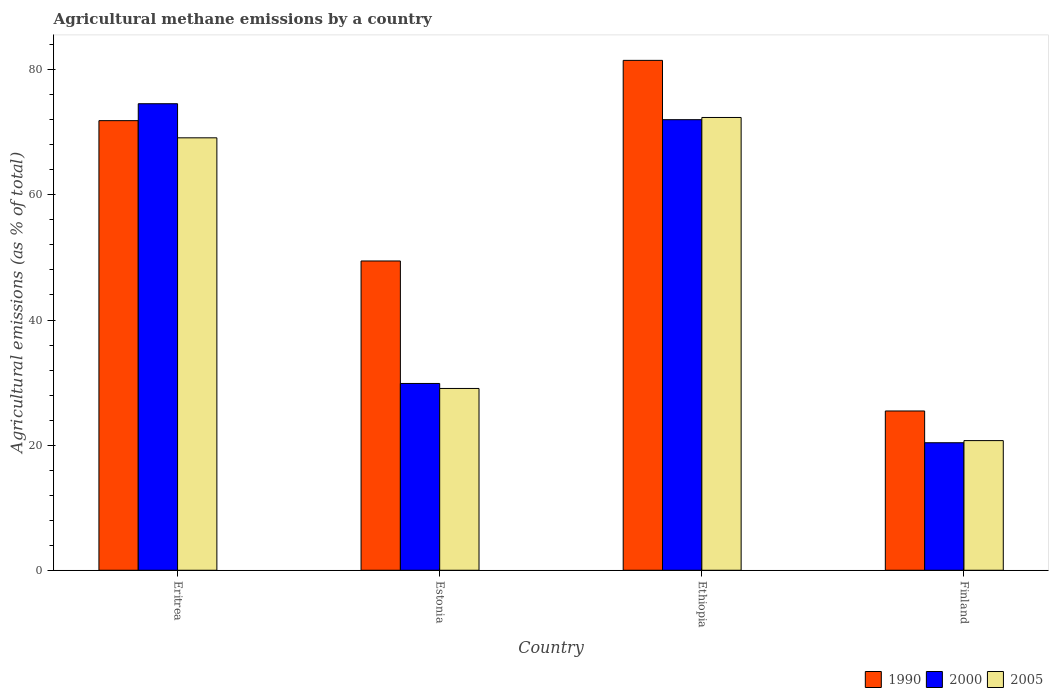How many different coloured bars are there?
Offer a very short reply. 3. How many groups of bars are there?
Your response must be concise. 4. Are the number of bars per tick equal to the number of legend labels?
Give a very brief answer. Yes. How many bars are there on the 4th tick from the left?
Your answer should be compact. 3. How many bars are there on the 3rd tick from the right?
Offer a terse response. 3. What is the label of the 2nd group of bars from the left?
Provide a short and direct response. Estonia. In how many cases, is the number of bars for a given country not equal to the number of legend labels?
Your answer should be very brief. 0. What is the amount of agricultural methane emitted in 2000 in Finland?
Your answer should be very brief. 20.38. Across all countries, what is the maximum amount of agricultural methane emitted in 2000?
Make the answer very short. 74.57. Across all countries, what is the minimum amount of agricultural methane emitted in 2000?
Offer a very short reply. 20.38. In which country was the amount of agricultural methane emitted in 2000 maximum?
Ensure brevity in your answer.  Eritrea. What is the total amount of agricultural methane emitted in 2005 in the graph?
Your response must be concise. 191.29. What is the difference between the amount of agricultural methane emitted in 2000 in Eritrea and that in Ethiopia?
Your answer should be compact. 2.55. What is the difference between the amount of agricultural methane emitted in 2005 in Estonia and the amount of agricultural methane emitted in 2000 in Finland?
Give a very brief answer. 8.68. What is the average amount of agricultural methane emitted in 2005 per country?
Make the answer very short. 47.82. What is the difference between the amount of agricultural methane emitted of/in 2005 and amount of agricultural methane emitted of/in 2000 in Estonia?
Ensure brevity in your answer.  -0.8. What is the ratio of the amount of agricultural methane emitted in 2000 in Estonia to that in Ethiopia?
Provide a short and direct response. 0.41. Is the amount of agricultural methane emitted in 2005 in Eritrea less than that in Finland?
Offer a very short reply. No. What is the difference between the highest and the second highest amount of agricultural methane emitted in 1990?
Your answer should be compact. 32.07. What is the difference between the highest and the lowest amount of agricultural methane emitted in 2000?
Your answer should be compact. 54.19. Is the sum of the amount of agricultural methane emitted in 2000 in Estonia and Finland greater than the maximum amount of agricultural methane emitted in 1990 across all countries?
Your answer should be very brief. No. What does the 3rd bar from the left in Finland represents?
Your answer should be compact. 2005. How many bars are there?
Your answer should be very brief. 12. Are all the bars in the graph horizontal?
Provide a short and direct response. No. What is the difference between two consecutive major ticks on the Y-axis?
Ensure brevity in your answer.  20. Are the values on the major ticks of Y-axis written in scientific E-notation?
Your answer should be compact. No. Does the graph contain any zero values?
Offer a terse response. No. How many legend labels are there?
Provide a succinct answer. 3. How are the legend labels stacked?
Give a very brief answer. Horizontal. What is the title of the graph?
Provide a short and direct response. Agricultural methane emissions by a country. What is the label or title of the Y-axis?
Make the answer very short. Agricultural emissions (as % of total). What is the Agricultural emissions (as % of total) of 1990 in Eritrea?
Your answer should be very brief. 71.87. What is the Agricultural emissions (as % of total) of 2000 in Eritrea?
Offer a very short reply. 74.57. What is the Agricultural emissions (as % of total) in 2005 in Eritrea?
Your answer should be compact. 69.12. What is the Agricultural emissions (as % of total) in 1990 in Estonia?
Keep it short and to the point. 49.44. What is the Agricultural emissions (as % of total) in 2000 in Estonia?
Offer a terse response. 29.86. What is the Agricultural emissions (as % of total) in 2005 in Estonia?
Your answer should be compact. 29.06. What is the Agricultural emissions (as % of total) of 1990 in Ethiopia?
Your response must be concise. 81.5. What is the Agricultural emissions (as % of total) in 2000 in Ethiopia?
Give a very brief answer. 72.02. What is the Agricultural emissions (as % of total) in 2005 in Ethiopia?
Keep it short and to the point. 72.38. What is the Agricultural emissions (as % of total) in 1990 in Finland?
Provide a succinct answer. 25.46. What is the Agricultural emissions (as % of total) of 2000 in Finland?
Ensure brevity in your answer.  20.38. What is the Agricultural emissions (as % of total) of 2005 in Finland?
Keep it short and to the point. 20.73. Across all countries, what is the maximum Agricultural emissions (as % of total) of 1990?
Keep it short and to the point. 81.5. Across all countries, what is the maximum Agricultural emissions (as % of total) in 2000?
Keep it short and to the point. 74.57. Across all countries, what is the maximum Agricultural emissions (as % of total) of 2005?
Provide a short and direct response. 72.38. Across all countries, what is the minimum Agricultural emissions (as % of total) of 1990?
Give a very brief answer. 25.46. Across all countries, what is the minimum Agricultural emissions (as % of total) of 2000?
Ensure brevity in your answer.  20.38. Across all countries, what is the minimum Agricultural emissions (as % of total) of 2005?
Your answer should be compact. 20.73. What is the total Agricultural emissions (as % of total) in 1990 in the graph?
Your answer should be compact. 228.27. What is the total Agricultural emissions (as % of total) in 2000 in the graph?
Keep it short and to the point. 196.84. What is the total Agricultural emissions (as % of total) in 2005 in the graph?
Make the answer very short. 191.29. What is the difference between the Agricultural emissions (as % of total) of 1990 in Eritrea and that in Estonia?
Keep it short and to the point. 22.43. What is the difference between the Agricultural emissions (as % of total) of 2000 in Eritrea and that in Estonia?
Provide a short and direct response. 44.71. What is the difference between the Agricultural emissions (as % of total) in 2005 in Eritrea and that in Estonia?
Offer a terse response. 40.06. What is the difference between the Agricultural emissions (as % of total) in 1990 in Eritrea and that in Ethiopia?
Your answer should be very brief. -9.64. What is the difference between the Agricultural emissions (as % of total) of 2000 in Eritrea and that in Ethiopia?
Your answer should be very brief. 2.55. What is the difference between the Agricultural emissions (as % of total) in 2005 in Eritrea and that in Ethiopia?
Provide a succinct answer. -3.25. What is the difference between the Agricultural emissions (as % of total) of 1990 in Eritrea and that in Finland?
Provide a succinct answer. 46.41. What is the difference between the Agricultural emissions (as % of total) of 2000 in Eritrea and that in Finland?
Keep it short and to the point. 54.19. What is the difference between the Agricultural emissions (as % of total) in 2005 in Eritrea and that in Finland?
Offer a terse response. 48.4. What is the difference between the Agricultural emissions (as % of total) of 1990 in Estonia and that in Ethiopia?
Offer a very short reply. -32.07. What is the difference between the Agricultural emissions (as % of total) of 2000 in Estonia and that in Ethiopia?
Keep it short and to the point. -42.16. What is the difference between the Agricultural emissions (as % of total) in 2005 in Estonia and that in Ethiopia?
Offer a terse response. -43.32. What is the difference between the Agricultural emissions (as % of total) in 1990 in Estonia and that in Finland?
Offer a very short reply. 23.98. What is the difference between the Agricultural emissions (as % of total) of 2000 in Estonia and that in Finland?
Provide a short and direct response. 9.48. What is the difference between the Agricultural emissions (as % of total) in 2005 in Estonia and that in Finland?
Your answer should be very brief. 8.33. What is the difference between the Agricultural emissions (as % of total) of 1990 in Ethiopia and that in Finland?
Your answer should be very brief. 56.04. What is the difference between the Agricultural emissions (as % of total) of 2000 in Ethiopia and that in Finland?
Offer a terse response. 51.64. What is the difference between the Agricultural emissions (as % of total) in 2005 in Ethiopia and that in Finland?
Keep it short and to the point. 51.65. What is the difference between the Agricultural emissions (as % of total) in 1990 in Eritrea and the Agricultural emissions (as % of total) in 2000 in Estonia?
Your answer should be very brief. 42.01. What is the difference between the Agricultural emissions (as % of total) in 1990 in Eritrea and the Agricultural emissions (as % of total) in 2005 in Estonia?
Your answer should be very brief. 42.81. What is the difference between the Agricultural emissions (as % of total) in 2000 in Eritrea and the Agricultural emissions (as % of total) in 2005 in Estonia?
Make the answer very short. 45.51. What is the difference between the Agricultural emissions (as % of total) in 1990 in Eritrea and the Agricultural emissions (as % of total) in 2000 in Ethiopia?
Offer a terse response. -0.16. What is the difference between the Agricultural emissions (as % of total) in 1990 in Eritrea and the Agricultural emissions (as % of total) in 2005 in Ethiopia?
Your response must be concise. -0.51. What is the difference between the Agricultural emissions (as % of total) in 2000 in Eritrea and the Agricultural emissions (as % of total) in 2005 in Ethiopia?
Your response must be concise. 2.2. What is the difference between the Agricultural emissions (as % of total) of 1990 in Eritrea and the Agricultural emissions (as % of total) of 2000 in Finland?
Your answer should be compact. 51.48. What is the difference between the Agricultural emissions (as % of total) of 1990 in Eritrea and the Agricultural emissions (as % of total) of 2005 in Finland?
Give a very brief answer. 51.14. What is the difference between the Agricultural emissions (as % of total) of 2000 in Eritrea and the Agricultural emissions (as % of total) of 2005 in Finland?
Offer a terse response. 53.85. What is the difference between the Agricultural emissions (as % of total) of 1990 in Estonia and the Agricultural emissions (as % of total) of 2000 in Ethiopia?
Keep it short and to the point. -22.59. What is the difference between the Agricultural emissions (as % of total) in 1990 in Estonia and the Agricultural emissions (as % of total) in 2005 in Ethiopia?
Keep it short and to the point. -22.94. What is the difference between the Agricultural emissions (as % of total) in 2000 in Estonia and the Agricultural emissions (as % of total) in 2005 in Ethiopia?
Offer a terse response. -42.52. What is the difference between the Agricultural emissions (as % of total) of 1990 in Estonia and the Agricultural emissions (as % of total) of 2000 in Finland?
Your answer should be compact. 29.05. What is the difference between the Agricultural emissions (as % of total) in 1990 in Estonia and the Agricultural emissions (as % of total) in 2005 in Finland?
Your answer should be compact. 28.71. What is the difference between the Agricultural emissions (as % of total) in 2000 in Estonia and the Agricultural emissions (as % of total) in 2005 in Finland?
Offer a very short reply. 9.13. What is the difference between the Agricultural emissions (as % of total) in 1990 in Ethiopia and the Agricultural emissions (as % of total) in 2000 in Finland?
Your answer should be very brief. 61.12. What is the difference between the Agricultural emissions (as % of total) of 1990 in Ethiopia and the Agricultural emissions (as % of total) of 2005 in Finland?
Offer a very short reply. 60.78. What is the difference between the Agricultural emissions (as % of total) in 2000 in Ethiopia and the Agricultural emissions (as % of total) in 2005 in Finland?
Provide a succinct answer. 51.3. What is the average Agricultural emissions (as % of total) of 1990 per country?
Provide a short and direct response. 57.07. What is the average Agricultural emissions (as % of total) in 2000 per country?
Offer a terse response. 49.21. What is the average Agricultural emissions (as % of total) in 2005 per country?
Ensure brevity in your answer.  47.82. What is the difference between the Agricultural emissions (as % of total) of 1990 and Agricultural emissions (as % of total) of 2000 in Eritrea?
Offer a terse response. -2.71. What is the difference between the Agricultural emissions (as % of total) in 1990 and Agricultural emissions (as % of total) in 2005 in Eritrea?
Your response must be concise. 2.75. What is the difference between the Agricultural emissions (as % of total) of 2000 and Agricultural emissions (as % of total) of 2005 in Eritrea?
Your answer should be very brief. 5.45. What is the difference between the Agricultural emissions (as % of total) of 1990 and Agricultural emissions (as % of total) of 2000 in Estonia?
Provide a succinct answer. 19.58. What is the difference between the Agricultural emissions (as % of total) in 1990 and Agricultural emissions (as % of total) in 2005 in Estonia?
Ensure brevity in your answer.  20.38. What is the difference between the Agricultural emissions (as % of total) of 2000 and Agricultural emissions (as % of total) of 2005 in Estonia?
Your answer should be very brief. 0.8. What is the difference between the Agricultural emissions (as % of total) in 1990 and Agricultural emissions (as % of total) in 2000 in Ethiopia?
Your answer should be very brief. 9.48. What is the difference between the Agricultural emissions (as % of total) of 1990 and Agricultural emissions (as % of total) of 2005 in Ethiopia?
Ensure brevity in your answer.  9.13. What is the difference between the Agricultural emissions (as % of total) of 2000 and Agricultural emissions (as % of total) of 2005 in Ethiopia?
Make the answer very short. -0.35. What is the difference between the Agricultural emissions (as % of total) in 1990 and Agricultural emissions (as % of total) in 2000 in Finland?
Your response must be concise. 5.08. What is the difference between the Agricultural emissions (as % of total) of 1990 and Agricultural emissions (as % of total) of 2005 in Finland?
Your answer should be very brief. 4.74. What is the difference between the Agricultural emissions (as % of total) in 2000 and Agricultural emissions (as % of total) in 2005 in Finland?
Make the answer very short. -0.34. What is the ratio of the Agricultural emissions (as % of total) in 1990 in Eritrea to that in Estonia?
Offer a very short reply. 1.45. What is the ratio of the Agricultural emissions (as % of total) of 2000 in Eritrea to that in Estonia?
Your response must be concise. 2.5. What is the ratio of the Agricultural emissions (as % of total) in 2005 in Eritrea to that in Estonia?
Keep it short and to the point. 2.38. What is the ratio of the Agricultural emissions (as % of total) in 1990 in Eritrea to that in Ethiopia?
Make the answer very short. 0.88. What is the ratio of the Agricultural emissions (as % of total) of 2000 in Eritrea to that in Ethiopia?
Provide a short and direct response. 1.04. What is the ratio of the Agricultural emissions (as % of total) in 2005 in Eritrea to that in Ethiopia?
Offer a very short reply. 0.96. What is the ratio of the Agricultural emissions (as % of total) of 1990 in Eritrea to that in Finland?
Make the answer very short. 2.82. What is the ratio of the Agricultural emissions (as % of total) of 2000 in Eritrea to that in Finland?
Your answer should be compact. 3.66. What is the ratio of the Agricultural emissions (as % of total) in 2005 in Eritrea to that in Finland?
Provide a short and direct response. 3.34. What is the ratio of the Agricultural emissions (as % of total) in 1990 in Estonia to that in Ethiopia?
Keep it short and to the point. 0.61. What is the ratio of the Agricultural emissions (as % of total) of 2000 in Estonia to that in Ethiopia?
Offer a terse response. 0.41. What is the ratio of the Agricultural emissions (as % of total) in 2005 in Estonia to that in Ethiopia?
Make the answer very short. 0.4. What is the ratio of the Agricultural emissions (as % of total) of 1990 in Estonia to that in Finland?
Your answer should be very brief. 1.94. What is the ratio of the Agricultural emissions (as % of total) in 2000 in Estonia to that in Finland?
Keep it short and to the point. 1.46. What is the ratio of the Agricultural emissions (as % of total) in 2005 in Estonia to that in Finland?
Offer a terse response. 1.4. What is the ratio of the Agricultural emissions (as % of total) of 1990 in Ethiopia to that in Finland?
Keep it short and to the point. 3.2. What is the ratio of the Agricultural emissions (as % of total) of 2000 in Ethiopia to that in Finland?
Provide a succinct answer. 3.53. What is the ratio of the Agricultural emissions (as % of total) of 2005 in Ethiopia to that in Finland?
Ensure brevity in your answer.  3.49. What is the difference between the highest and the second highest Agricultural emissions (as % of total) in 1990?
Your answer should be compact. 9.64. What is the difference between the highest and the second highest Agricultural emissions (as % of total) in 2000?
Give a very brief answer. 2.55. What is the difference between the highest and the second highest Agricultural emissions (as % of total) in 2005?
Your response must be concise. 3.25. What is the difference between the highest and the lowest Agricultural emissions (as % of total) in 1990?
Offer a very short reply. 56.04. What is the difference between the highest and the lowest Agricultural emissions (as % of total) of 2000?
Ensure brevity in your answer.  54.19. What is the difference between the highest and the lowest Agricultural emissions (as % of total) of 2005?
Your answer should be very brief. 51.65. 